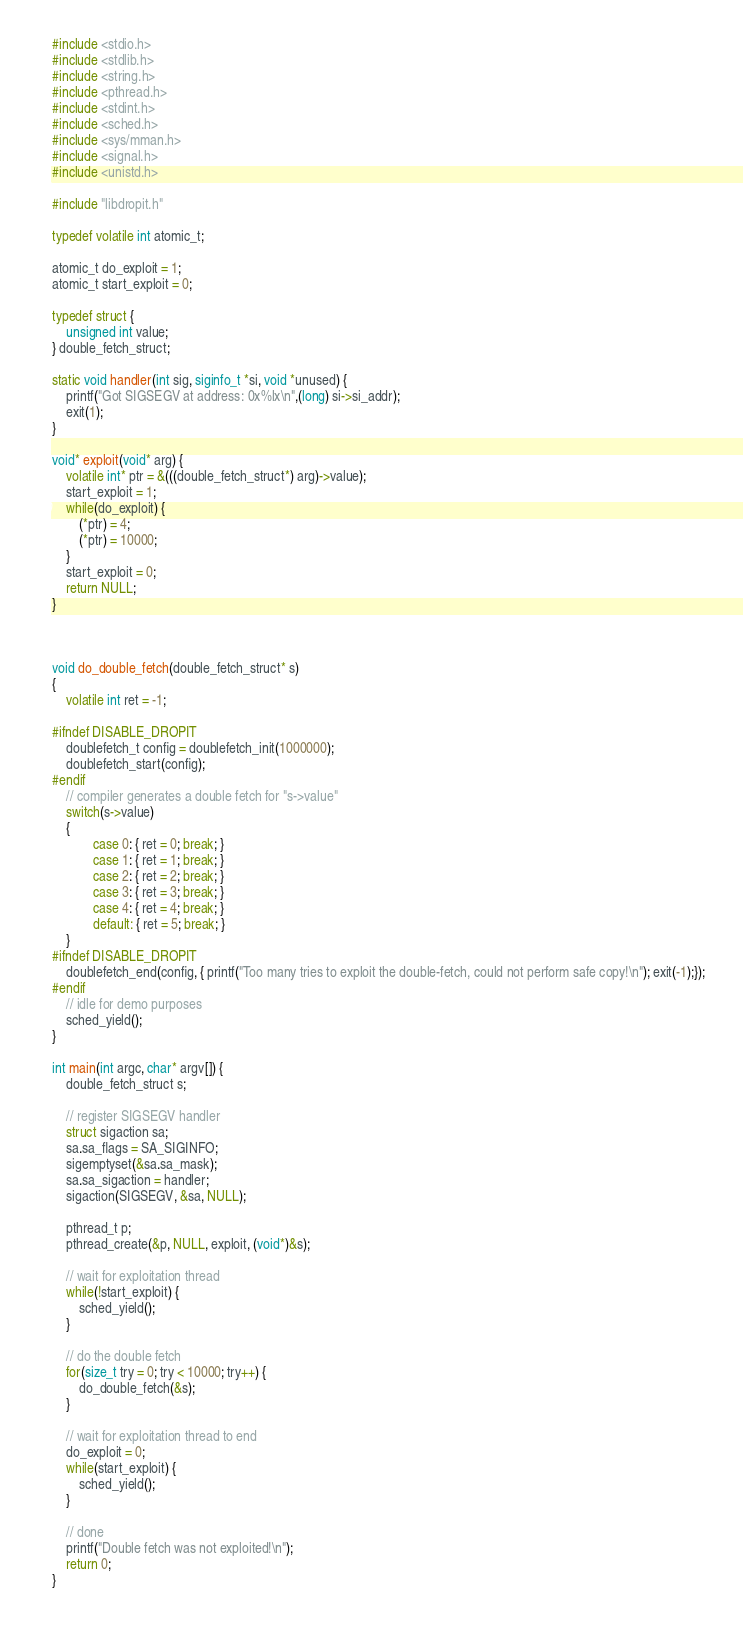Convert code to text. <code><loc_0><loc_0><loc_500><loc_500><_C_>#include <stdio.h>
#include <stdlib.h>
#include <string.h>
#include <pthread.h>
#include <stdint.h>
#include <sched.h>
#include <sys/mman.h>
#include <signal.h>
#include <unistd.h>

#include "libdropit.h"

typedef volatile int atomic_t;

atomic_t do_exploit = 1;
atomic_t start_exploit = 0;

typedef struct {
    unsigned int value;
} double_fetch_struct;

static void handler(int sig, siginfo_t *si, void *unused) {
    printf("Got SIGSEGV at address: 0x%lx\n",(long) si->si_addr);
    exit(1);
}

void* exploit(void* arg) {
    volatile int* ptr = &(((double_fetch_struct*) arg)->value);
    start_exploit = 1;
    while(do_exploit) {
        (*ptr) = 4;
        (*ptr) = 10000;
    }
    start_exploit = 0;
    return NULL;
}



void do_double_fetch(double_fetch_struct* s)
{
    volatile int ret = -1;

#ifndef DISABLE_DROPIT
    doublefetch_t config = doublefetch_init(1000000);
    doublefetch_start(config);
#endif
    // compiler generates a double fetch for "s->value"
    switch(s->value)
    {
            case 0: { ret = 0; break; }
            case 1: { ret = 1; break; }
            case 2: { ret = 2; break; }
            case 3: { ret = 3; break; }
            case 4: { ret = 4; break; }
            default: { ret = 5; break; }
    }
#ifndef DISABLE_DROPIT
    doublefetch_end(config, { printf("Too many tries to exploit the double-fetch, could not perform safe copy!\n"); exit(-1);});
#endif
    // idle for demo purposes
    sched_yield();
}

int main(int argc, char* argv[]) {
    double_fetch_struct s;

    // register SIGSEGV handler
    struct sigaction sa;
    sa.sa_flags = SA_SIGINFO;
    sigemptyset(&sa.sa_mask);
    sa.sa_sigaction = handler;
    sigaction(SIGSEGV, &sa, NULL);

    pthread_t p;
    pthread_create(&p, NULL, exploit, (void*)&s);
    
    // wait for exploitation thread
    while(!start_exploit) {
        sched_yield();
    }

    // do the double fetch
    for(size_t try = 0; try < 10000; try++) {
        do_double_fetch(&s);
    }
    
    // wait for exploitation thread to end
    do_exploit = 0;
    while(start_exploit) {
        sched_yield();
    }
    
    // done
    printf("Double fetch was not exploited!\n");
    return 0;
}
</code> 